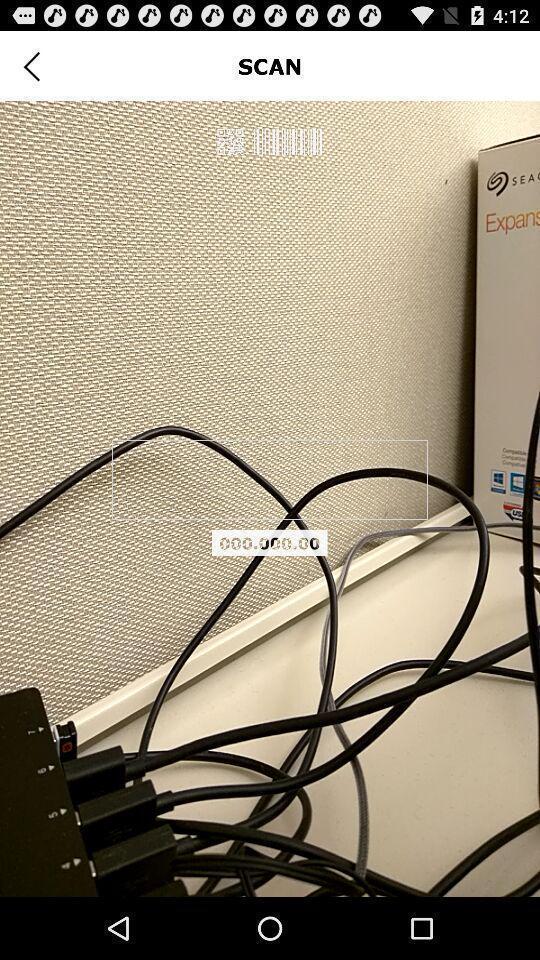Tell me about the visual elements in this screen capture. Scan page of the app. 